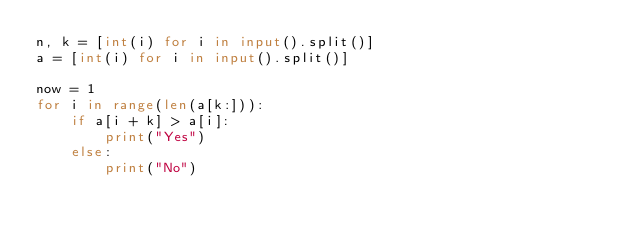<code> <loc_0><loc_0><loc_500><loc_500><_Python_>n, k = [int(i) for i in input().split()]
a = [int(i) for i in input().split()]

now = 1
for i in range(len(a[k:])):
    if a[i + k] > a[i]:
        print("Yes")
    else:
        print("No")</code> 